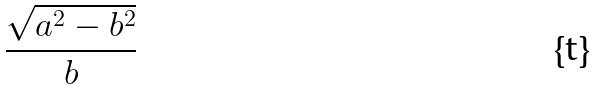Convert formula to latex. <formula><loc_0><loc_0><loc_500><loc_500>\frac { \sqrt { a ^ { 2 } - b ^ { 2 } } } { b }</formula> 